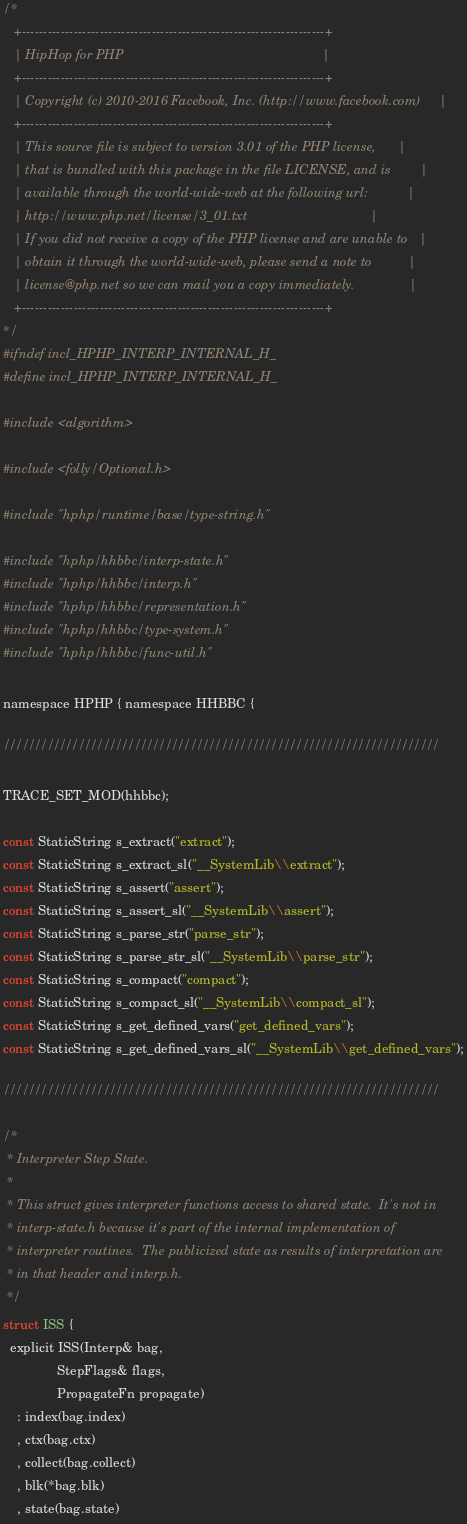<code> <loc_0><loc_0><loc_500><loc_500><_C_>/*
   +----------------------------------------------------------------------+
   | HipHop for PHP                                                       |
   +----------------------------------------------------------------------+
   | Copyright (c) 2010-2016 Facebook, Inc. (http://www.facebook.com)     |
   +----------------------------------------------------------------------+
   | This source file is subject to version 3.01 of the PHP license,      |
   | that is bundled with this package in the file LICENSE, and is        |
   | available through the world-wide-web at the following url:           |
   | http://www.php.net/license/3_01.txt                                  |
   | If you did not receive a copy of the PHP license and are unable to   |
   | obtain it through the world-wide-web, please send a note to          |
   | license@php.net so we can mail you a copy immediately.               |
   +----------------------------------------------------------------------+
*/
#ifndef incl_HPHP_INTERP_INTERNAL_H_
#define incl_HPHP_INTERP_INTERNAL_H_

#include <algorithm>

#include <folly/Optional.h>

#include "hphp/runtime/base/type-string.h"

#include "hphp/hhbbc/interp-state.h"
#include "hphp/hhbbc/interp.h"
#include "hphp/hhbbc/representation.h"
#include "hphp/hhbbc/type-system.h"
#include "hphp/hhbbc/func-util.h"

namespace HPHP { namespace HHBBC {

//////////////////////////////////////////////////////////////////////

TRACE_SET_MOD(hhbbc);

const StaticString s_extract("extract");
const StaticString s_extract_sl("__SystemLib\\extract");
const StaticString s_assert("assert");
const StaticString s_assert_sl("__SystemLib\\assert");
const StaticString s_parse_str("parse_str");
const StaticString s_parse_str_sl("__SystemLib\\parse_str");
const StaticString s_compact("compact");
const StaticString s_compact_sl("__SystemLib\\compact_sl");
const StaticString s_get_defined_vars("get_defined_vars");
const StaticString s_get_defined_vars_sl("__SystemLib\\get_defined_vars");

//////////////////////////////////////////////////////////////////////

/*
 * Interpreter Step State.
 *
 * This struct gives interpreter functions access to shared state.  It's not in
 * interp-state.h because it's part of the internal implementation of
 * interpreter routines.  The publicized state as results of interpretation are
 * in that header and interp.h.
 */
struct ISS {
  explicit ISS(Interp& bag,
               StepFlags& flags,
               PropagateFn propagate)
    : index(bag.index)
    , ctx(bag.ctx)
    , collect(bag.collect)
    , blk(*bag.blk)
    , state(bag.state)</code> 